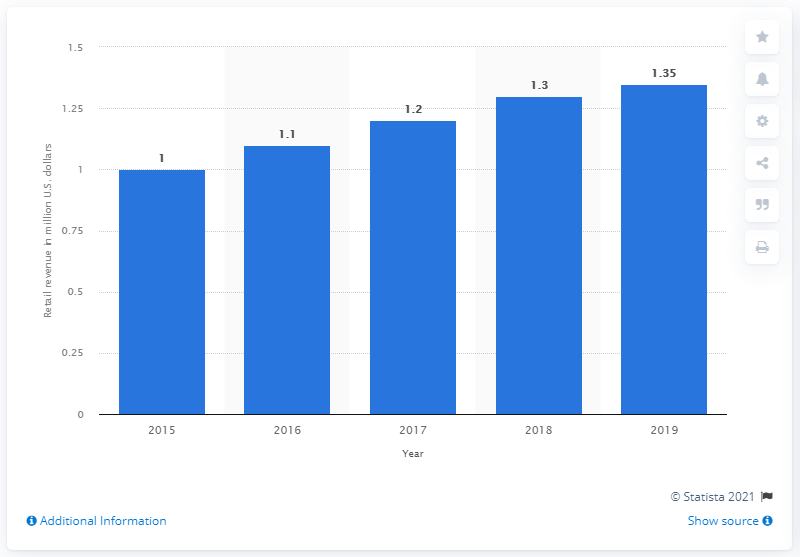Draw attention to some important aspects in this diagram. In 2019, the Peppa Pig brand generated a total of 1.35 billion US dollars in retail sales worldwide. 